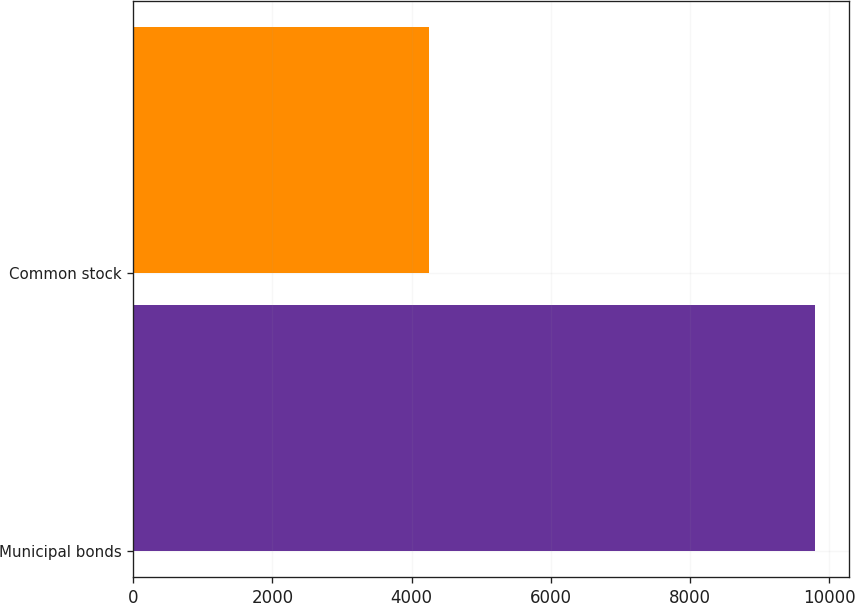<chart> <loc_0><loc_0><loc_500><loc_500><bar_chart><fcel>Municipal bonds<fcel>Common stock<nl><fcel>9797<fcel>4250<nl></chart> 